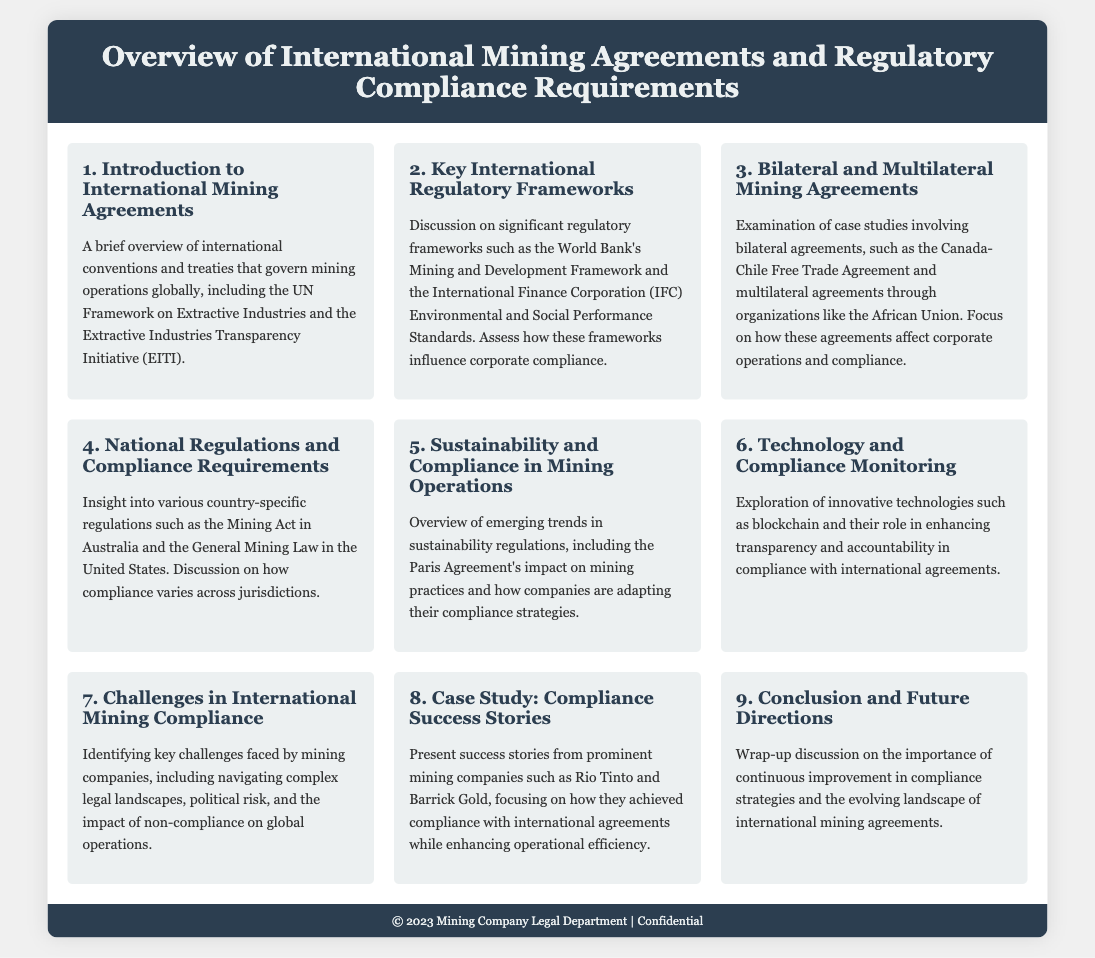What is the first agenda item? The first agenda item is about providing an introduction to international mining agreements.
Answer: Introduction to International Mining Agreements What international initiative is mentioned in the introduction? The introduction mentions the Extractive Industries Transparency Initiative (EITI).
Answer: Extractive Industries Transparency Initiative What regulatory framework is associated with the World Bank? The document discusses the World Bank's Mining and Development Framework in the key international regulatory frameworks section.
Answer: Mining and Development Framework Which agreement is highlighted as a bilateral mining agreement? The Canada-Chile Free Trade Agreement is specified as a bilateral agreement.
Answer: Canada-Chile Free Trade Agreement What act is referenced as a national regulation in Australia? The Mining Act in Australia is mentioned in the national regulations section.
Answer: Mining Act What is the focus of the fifth agenda item? The fifth agenda item focuses on sustainability and its compliance in mining operations.
Answer: Sustainability and Compliance in Mining Operations What technology is explored for compliance monitoring? The document explores blockchain technology for enhancing compliance monitoring.
Answer: Blockchain How many challenges in international mining compliance are identified? The document identifies several challenges, but it does not specify a numerical count directly.
Answer: Key challenges What companies are mentioned in the case study of compliance success stories? The compliance success stories feature prominent mining companies such as Rio Tinto and Barrick Gold.
Answer: Rio Tinto and Barrick Gold What is concluded about future compliance strategies? The conclusion discusses the importance of continuous improvement in compliance strategies.
Answer: Continuous improvement in compliance strategies 